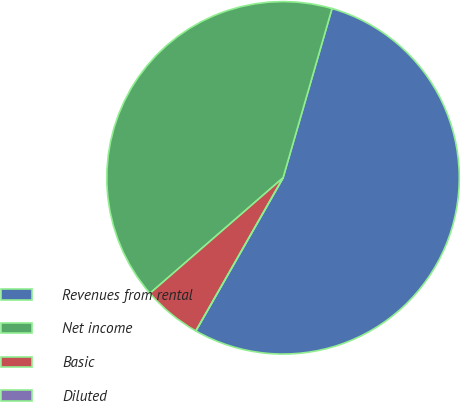Convert chart to OTSL. <chart><loc_0><loc_0><loc_500><loc_500><pie_chart><fcel>Revenues from rental<fcel>Net income<fcel>Basic<fcel>Diluted<nl><fcel>53.76%<fcel>40.86%<fcel>5.38%<fcel>0.0%<nl></chart> 